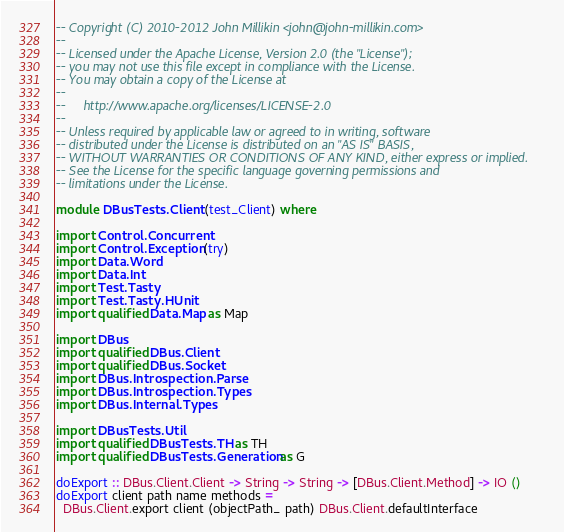<code> <loc_0><loc_0><loc_500><loc_500><_Haskell_>-- Copyright (C) 2010-2012 John Millikin <john@john-millikin.com>
--
-- Licensed under the Apache License, Version 2.0 (the "License");
-- you may not use this file except in compliance with the License.
-- You may obtain a copy of the License at
--
--     http://www.apache.org/licenses/LICENSE-2.0
--
-- Unless required by applicable law or agreed to in writing, software
-- distributed under the License is distributed on an "AS IS" BASIS,
-- WITHOUT WARRANTIES OR CONDITIONS OF ANY KIND, either express or implied.
-- See the License for the specific language governing permissions and
-- limitations under the License.

module DBusTests.Client (test_Client) where

import Control.Concurrent
import Control.Exception (try)
import Data.Word
import Data.Int
import Test.Tasty
import Test.Tasty.HUnit
import qualified Data.Map as Map

import DBus
import qualified DBus.Client
import qualified DBus.Socket
import DBus.Introspection.Parse
import DBus.Introspection.Types
import DBus.Internal.Types

import DBusTests.Util
import qualified DBusTests.TH as TH
import qualified DBusTests.Generation as G

doExport :: DBus.Client.Client -> String -> String -> [DBus.Client.Method] -> IO ()
doExport client path name methods =
  DBus.Client.export client (objectPath_ path) DBus.Client.defaultInterface</code> 